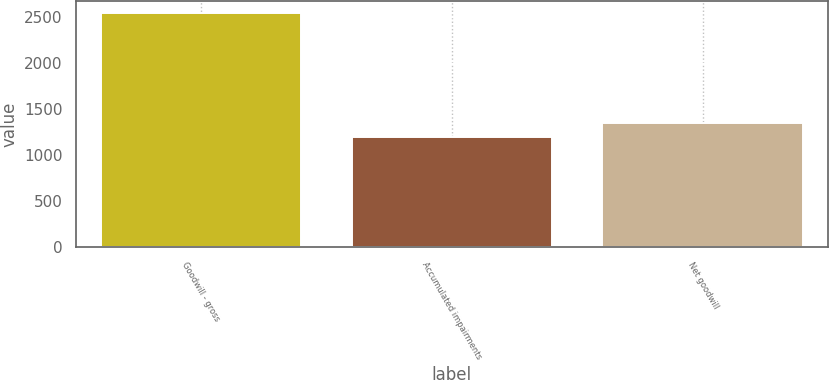Convert chart to OTSL. <chart><loc_0><loc_0><loc_500><loc_500><bar_chart><fcel>Goodwill - gross<fcel>Accumulated impairments<fcel>Net goodwill<nl><fcel>2546<fcel>1196<fcel>1350<nl></chart> 